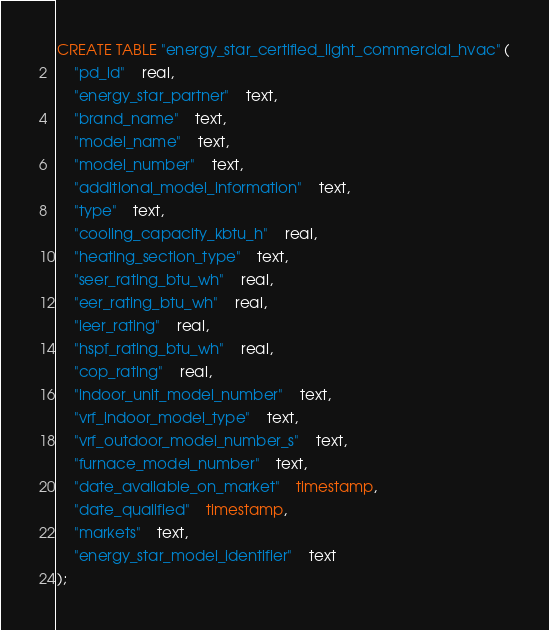<code> <loc_0><loc_0><loc_500><loc_500><_SQL_>CREATE TABLE "energy_star_certified_light_commercial_hvac" (
	"pd_id"	real,
	"energy_star_partner"	text,
	"brand_name"	text,
	"model_name"	text,
	"model_number"	text,
	"additional_model_information"	text,
	"type"	text,
	"cooling_capacity_kbtu_h"	real,
	"heating_section_type"	text,
	"seer_rating_btu_wh"	real,
	"eer_rating_btu_wh"	real,
	"ieer_rating"	real,
	"hspf_rating_btu_wh"	real,
	"cop_rating"	real,
	"indoor_unit_model_number"	text,
	"vrf_indoor_model_type"	text,
	"vrf_outdoor_model_number_s"	text,
	"furnace_model_number"	text,
	"date_available_on_market"	timestamp,
	"date_qualified"	timestamp,
	"markets"	text,
	"energy_star_model_identifier"	text
);
</code> 